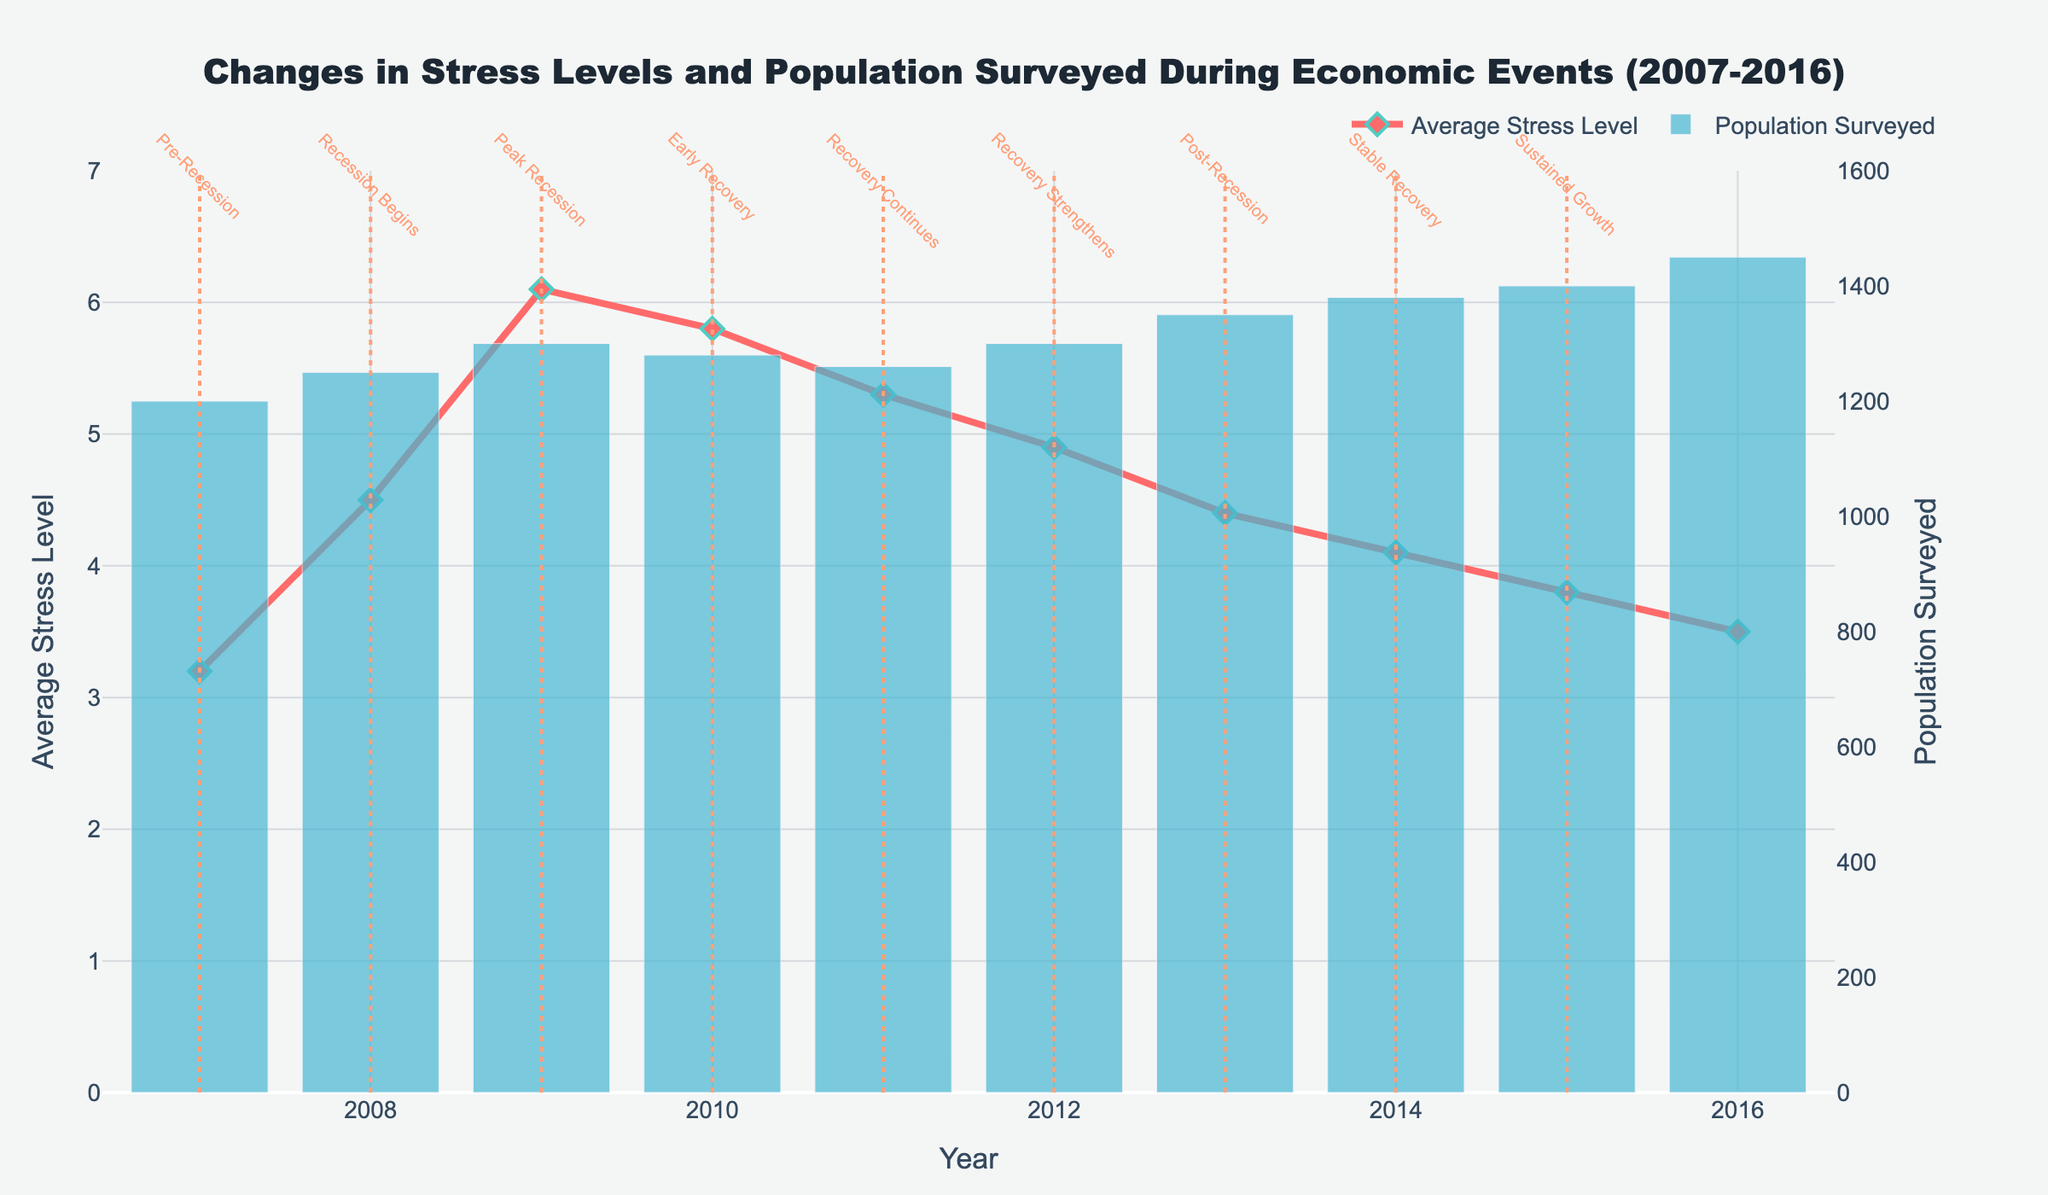How does the average stress level in 2008 compare to 2007? The average stress level in 2008 is 4.5, and in 2007, it is 3.2. Comparing these, we can see an increase.
Answer: Increased What is the trend in average stress level from 2009 to 2016? From the peak in 2009 with an average stress level of 6.1, the stress level consistently decreases to 3.5 by 2016, indicating a downward trend.
Answer: Downward During which year was the population surveyed the highest? The bar corresponding to the year 2016 is the tallest, indicating that the population surveyed was highest in that year.
Answer: 2016 What happens to the average stress level immediately following the start of the recession in 2008? The plot shows that, from 2008 to 2009, the average stress level increases from 4.5 to 6.1, marking a notable spike.
Answer: Increases Which notable event marks the beginning of the peak recession in the chart? The event marking the beginning of the peak recession is "Recession Begins" in 2008.
Answer: Recession Begins How much did the population surveyed change between 2008 and 2013? The population surveyed in 2008 is 1250, and in 2013 it is 1350. The change is 1350 - 1250 = 100.
Answer: 100 Which year had the highest stress level, and what was that level? The highest stress level is observed in the year 2009 with an average stress level of 6.1.
Answer: 2009; 6.1 Compare the average stress levels in the years labeled 'Early Recovery' and 'Stable Recovery'. The average stress level during 'Early Recovery' (2010) is 5.8, and during 'Stable Recovery' (2014) it is 4.1. Comparing these, 'Stable Recovery' has a lower stress level.
Answer: 'Early Recovery': 5.8, 'Stable Recovery': 4.1 Which period saw the most significant drop in average stress levels? From 2009 (6.1) to 2010 (5.8) is the largest single-year drop, but from 2009 (6.1) to 2016 (3.5) is the most significant over multiple years.
Answer: 2009 to 2010 (single-year); 2009 to 2016 (overall) What does the annotation on the year 2012 signify, and how does it correlate with the stress level trend? The annotation for 2012 notes "Recovery Strengthens," correlating with a decrease in the average stress level from 5.3 the previous year to 4.9.
Answer: Recovery Strengthens; Decrease 